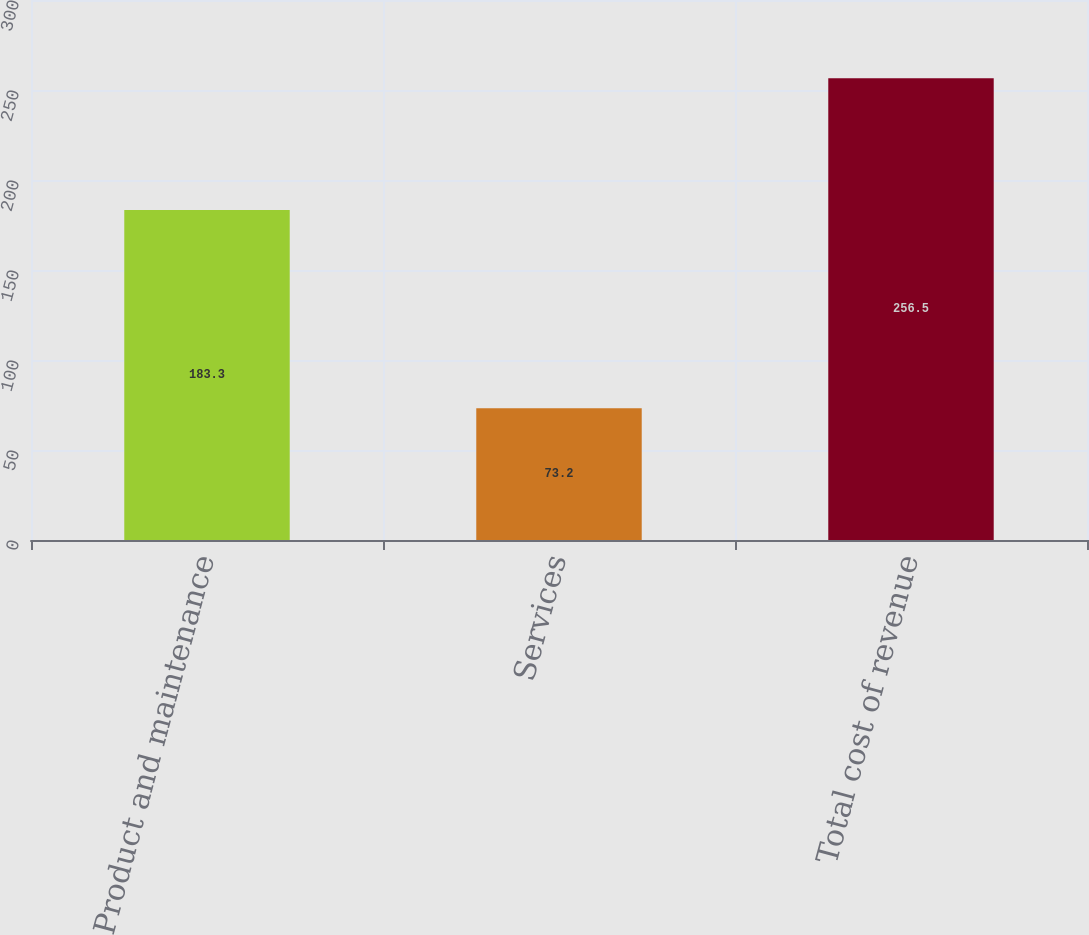Convert chart to OTSL. <chart><loc_0><loc_0><loc_500><loc_500><bar_chart><fcel>Product and maintenance<fcel>Services<fcel>Total cost of revenue<nl><fcel>183.3<fcel>73.2<fcel>256.5<nl></chart> 